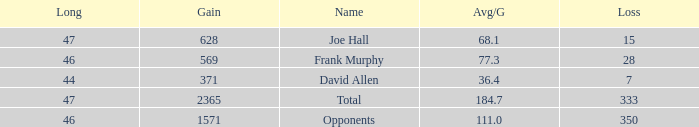How much Loss has a Gain smaller than 1571, and a Long smaller than 47, and an Avg/G of 36.4? 1.0. 